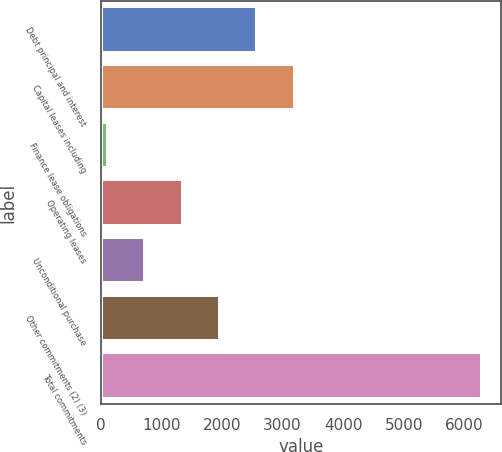Convert chart to OTSL. <chart><loc_0><loc_0><loc_500><loc_500><bar_chart><fcel>Debt principal and interest<fcel>Capital leases including<fcel>Finance lease obligations<fcel>Operating leases<fcel>Unconditional purchase<fcel>Other commitments (2) (3)<fcel>Total commitments<nl><fcel>2584.8<fcel>3203.5<fcel>110<fcel>1347.4<fcel>728.7<fcel>1966.1<fcel>6297<nl></chart> 